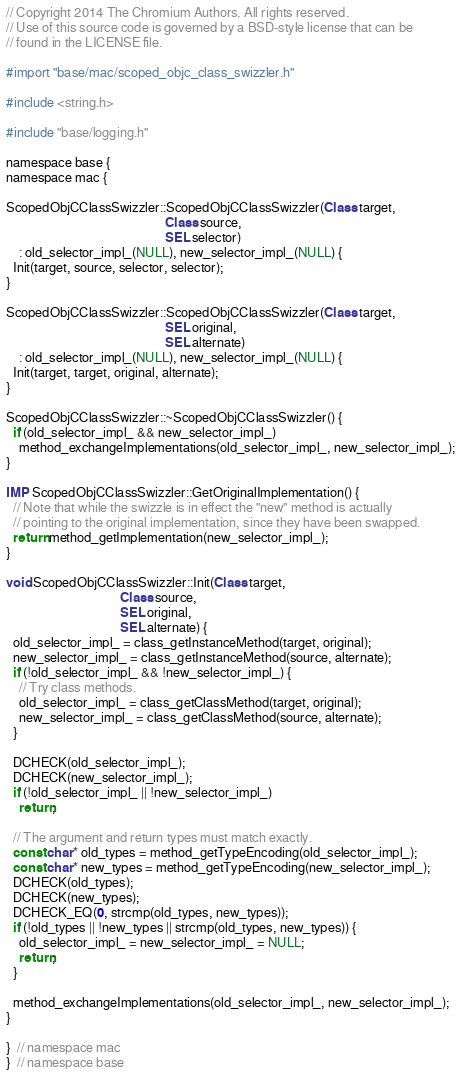Convert code to text. <code><loc_0><loc_0><loc_500><loc_500><_ObjectiveC_>// Copyright 2014 The Chromium Authors. All rights reserved.
// Use of this source code is governed by a BSD-style license that can be
// found in the LICENSE file.

#import "base/mac/scoped_objc_class_swizzler.h"

#include <string.h>

#include "base/logging.h"

namespace base {
namespace mac {

ScopedObjCClassSwizzler::ScopedObjCClassSwizzler(Class target,
                                                 Class source,
                                                 SEL selector)
    : old_selector_impl_(NULL), new_selector_impl_(NULL) {
  Init(target, source, selector, selector);
}

ScopedObjCClassSwizzler::ScopedObjCClassSwizzler(Class target,
                                                 SEL original,
                                                 SEL alternate)
    : old_selector_impl_(NULL), new_selector_impl_(NULL) {
  Init(target, target, original, alternate);
}

ScopedObjCClassSwizzler::~ScopedObjCClassSwizzler() {
  if (old_selector_impl_ && new_selector_impl_)
    method_exchangeImplementations(old_selector_impl_, new_selector_impl_);
}

IMP ScopedObjCClassSwizzler::GetOriginalImplementation() {
  // Note that while the swizzle is in effect the "new" method is actually
  // pointing to the original implementation, since they have been swapped.
  return method_getImplementation(new_selector_impl_);
}

void ScopedObjCClassSwizzler::Init(Class target,
                                   Class source,
                                   SEL original,
                                   SEL alternate) {
  old_selector_impl_ = class_getInstanceMethod(target, original);
  new_selector_impl_ = class_getInstanceMethod(source, alternate);
  if (!old_selector_impl_ && !new_selector_impl_) {
    // Try class methods.
    old_selector_impl_ = class_getClassMethod(target, original);
    new_selector_impl_ = class_getClassMethod(source, alternate);
  }

  DCHECK(old_selector_impl_);
  DCHECK(new_selector_impl_);
  if (!old_selector_impl_ || !new_selector_impl_)
    return;

  // The argument and return types must match exactly.
  const char* old_types = method_getTypeEncoding(old_selector_impl_);
  const char* new_types = method_getTypeEncoding(new_selector_impl_);
  DCHECK(old_types);
  DCHECK(new_types);
  DCHECK_EQ(0, strcmp(old_types, new_types));
  if (!old_types || !new_types || strcmp(old_types, new_types)) {
    old_selector_impl_ = new_selector_impl_ = NULL;
    return;
  }

  method_exchangeImplementations(old_selector_impl_, new_selector_impl_);
}

}  // namespace mac
}  // namespace base
</code> 